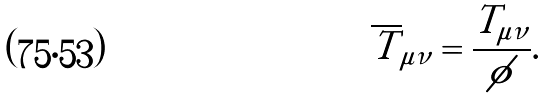<formula> <loc_0><loc_0><loc_500><loc_500>\overline { T } _ { \mu \nu } = \frac { T _ { \mu \nu } } { \phi } .</formula> 